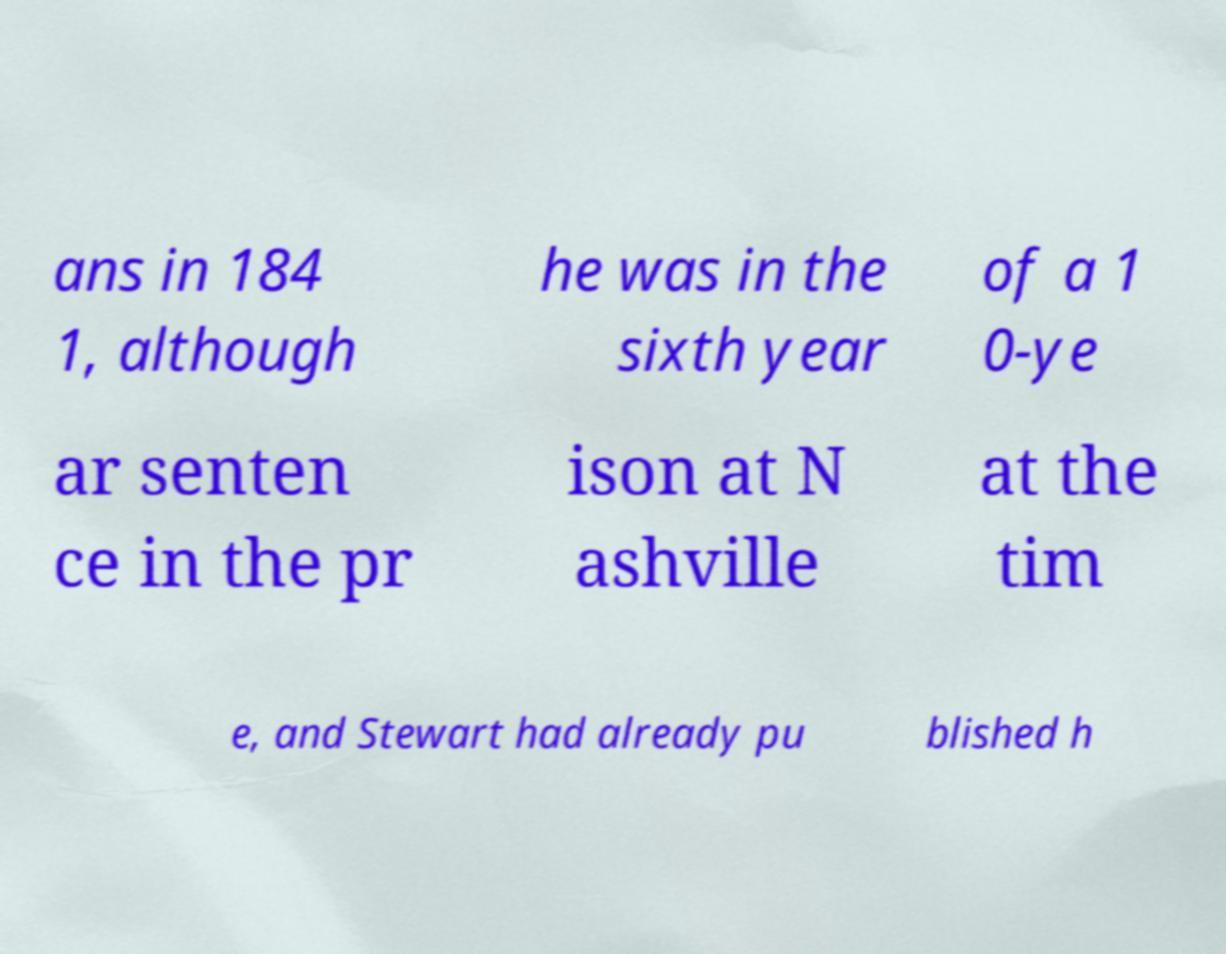What messages or text are displayed in this image? I need them in a readable, typed format. ans in 184 1, although he was in the sixth year of a 1 0-ye ar senten ce in the pr ison at N ashville at the tim e, and Stewart had already pu blished h 